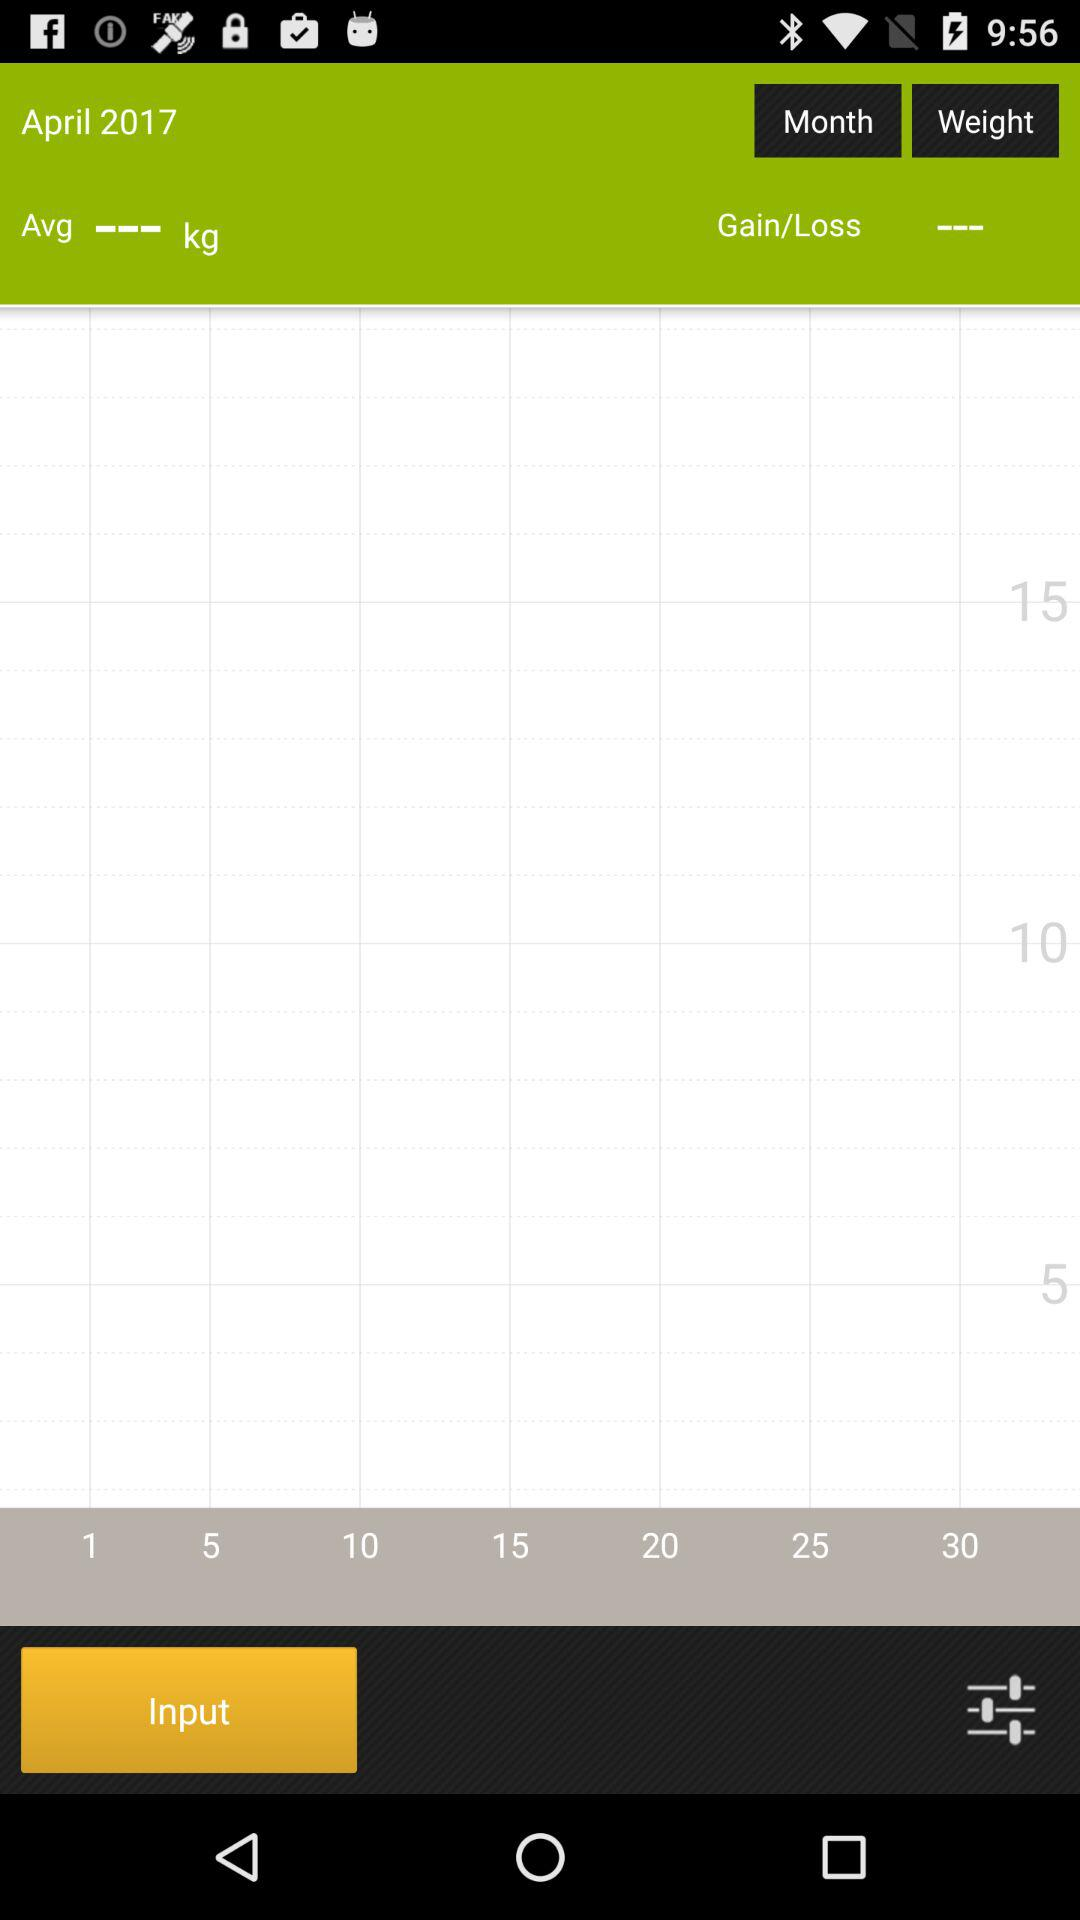How many more kilograms are there between the 15kg and 10kg labels on the grid?
Answer the question using a single word or phrase. 5 